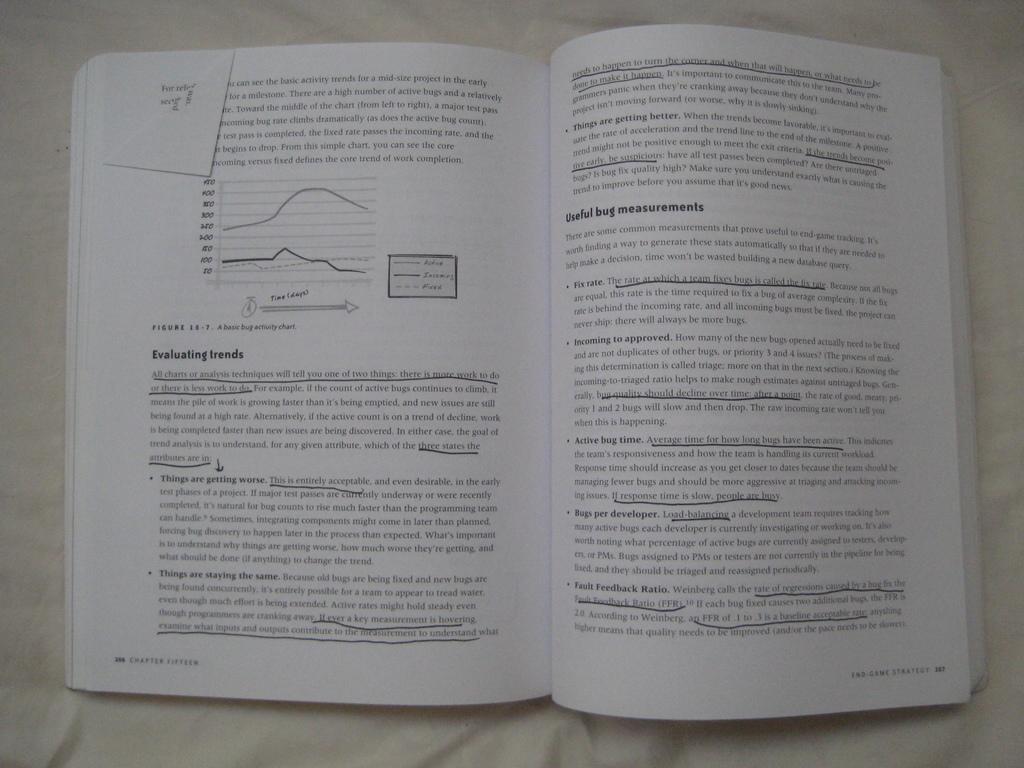What does the page on the left talk about evaluating?
Your answer should be compact. Trends. What is figure 18 - 7 displaying?
Your answer should be very brief. A basic bug activity chart. 